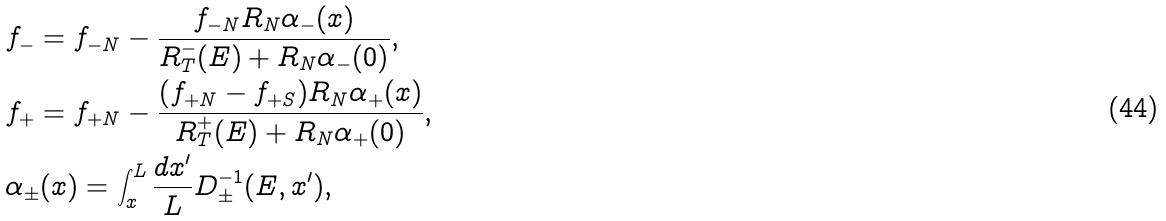<formula> <loc_0><loc_0><loc_500><loc_500>& f _ { - } = f _ { - N } - \frac { f _ { - N } R _ { N } \alpha _ { - } ( x ) } { R ^ { - } _ { T } ( E ) + R _ { N } \alpha _ { - } ( 0 ) } , \\ & f _ { + } = f _ { + N } - \frac { ( f _ { + N } - f _ { + S } ) R _ { N } \alpha _ { + } ( x ) } { R ^ { + } _ { T } ( E ) + R _ { N } \alpha _ { + } ( 0 ) } , \\ & \alpha _ { \pm } ( x ) = \int _ { x } ^ { L } \frac { d x ^ { \prime } } { L } D _ { \pm } ^ { - 1 } ( E , x ^ { \prime } ) ,</formula> 